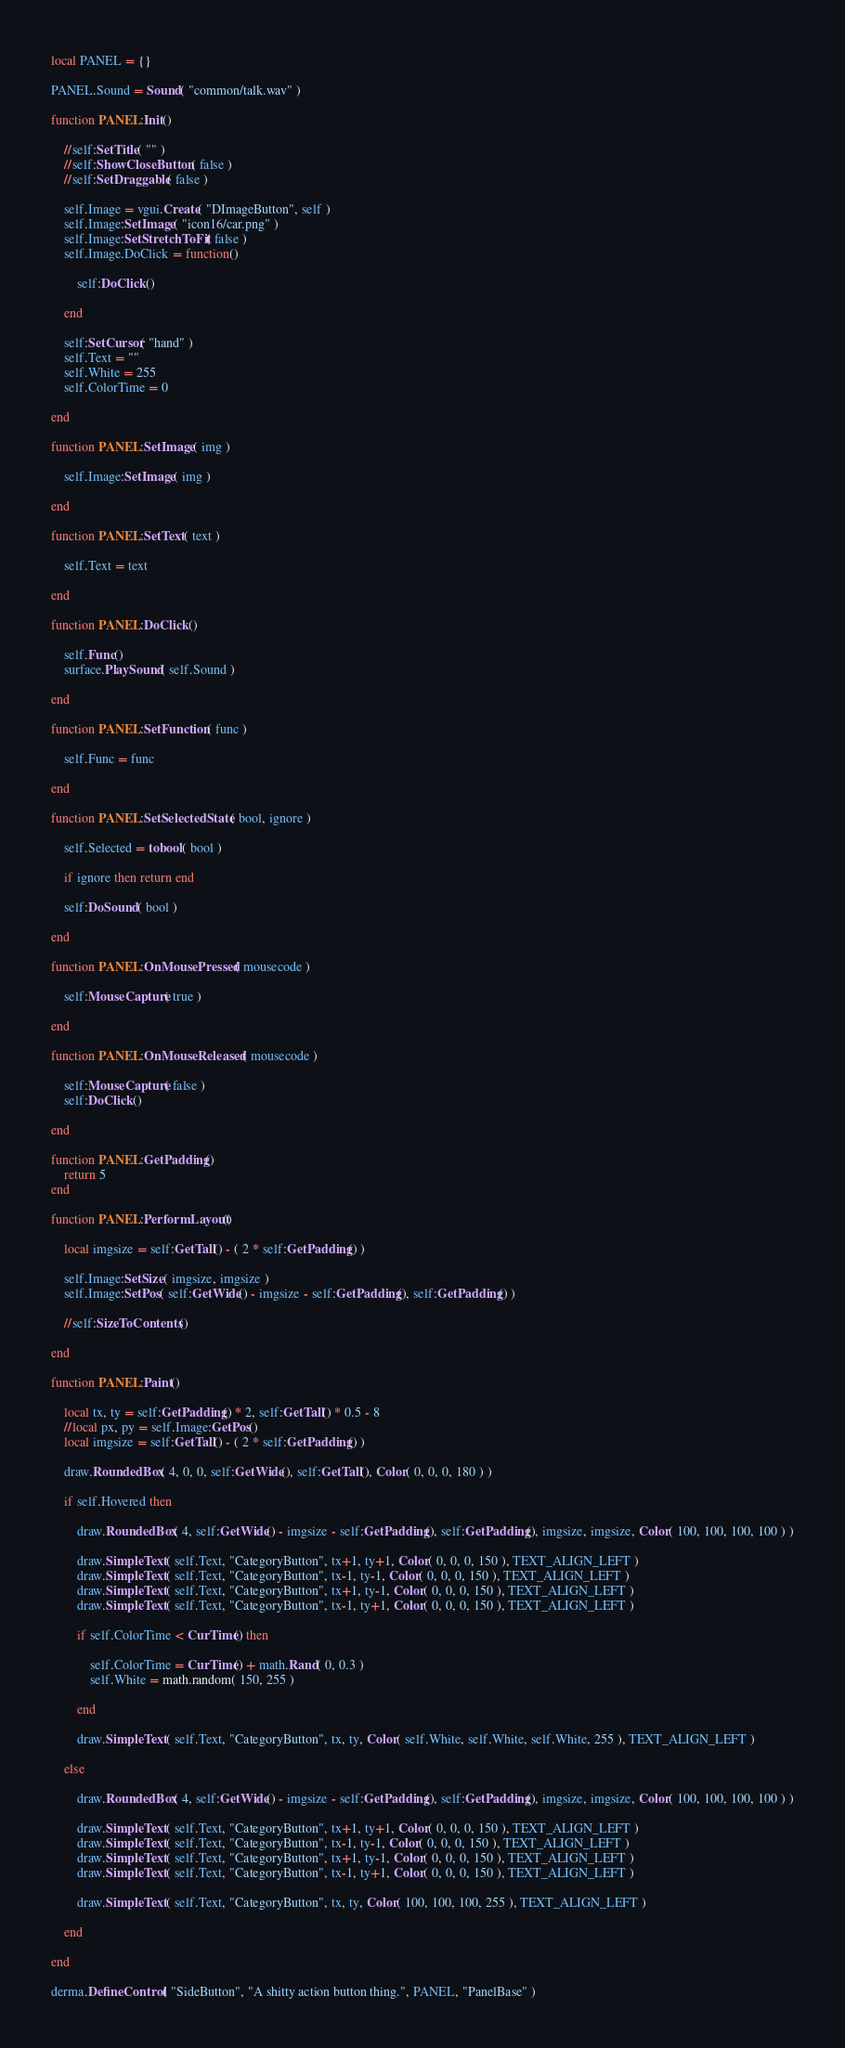Convert code to text. <code><loc_0><loc_0><loc_500><loc_500><_Lua_>local PANEL = {}

PANEL.Sound = Sound( "common/talk.wav" )

function PANEL:Init()

	//self:SetTitle( "" )
	//self:ShowCloseButton( false )
	//self:SetDraggable( false )
	
	self.Image = vgui.Create( "DImageButton", self )
	self.Image:SetImage( "icon16/car.png" )
	self.Image:SetStretchToFit( false )
	self.Image.DoClick = function()
	
		self:DoClick()
	
	end
	
	self:SetCursor( "hand" )
	self.Text = ""
	self.White = 255
	self.ColorTime = 0
	
end

function PANEL:SetImage( img )

	self.Image:SetImage( img )

end

function PANEL:SetText( text )

	self.Text = text

end

function PANEL:DoClick()

	self.Func()
	surface.PlaySound( self.Sound )

end

function PANEL:SetFunction( func ) 

	self.Func = func

end

function PANEL:SetSelectedState( bool, ignore )

	self.Selected = tobool( bool )
	
	if ignore then return end
	
	self:DoSound( bool )

end

function PANEL:OnMousePressed( mousecode )

	self:MouseCapture( true )

end

function PANEL:OnMouseReleased( mousecode )

	self:MouseCapture( false )
	self:DoClick()

end

function PANEL:GetPadding()
	return 5
end

function PANEL:PerformLayout()

	local imgsize = self:GetTall() - ( 2 * self:GetPadding() )

	self.Image:SetSize( imgsize, imgsize )
	self.Image:SetPos( self:GetWide() - imgsize - self:GetPadding(), self:GetPadding() )
	
	//self:SizeToContents()

end

function PANEL:Paint()

	local tx, ty = self:GetPadding() * 2, self:GetTall() * 0.5 - 8
	//local px, py = self.Image:GetPos()
	local imgsize = self:GetTall() - ( 2 * self:GetPadding() )

	draw.RoundedBox( 4, 0, 0, self:GetWide(), self:GetTall(), Color( 0, 0, 0, 180 ) )
	
	if self.Hovered then
	
		draw.RoundedBox( 4, self:GetWide() - imgsize - self:GetPadding(), self:GetPadding(), imgsize, imgsize, Color( 100, 100, 100, 100 ) )
		
		draw.SimpleText( self.Text, "CategoryButton", tx+1, ty+1, Color( 0, 0, 0, 150 ), TEXT_ALIGN_LEFT )
		draw.SimpleText( self.Text, "CategoryButton", tx-1, ty-1, Color( 0, 0, 0, 150 ), TEXT_ALIGN_LEFT )
		draw.SimpleText( self.Text, "CategoryButton", tx+1, ty-1, Color( 0, 0, 0, 150 ), TEXT_ALIGN_LEFT )
		draw.SimpleText( self.Text, "CategoryButton", tx-1, ty+1, Color( 0, 0, 0, 150 ), TEXT_ALIGN_LEFT )
		
		if self.ColorTime < CurTime() then
		
			self.ColorTime = CurTime() + math.Rand( 0, 0.3 )
			self.White = math.random( 150, 255 )
		
		end
		
		draw.SimpleText( self.Text, "CategoryButton", tx, ty, Color( self.White, self.White, self.White, 255 ), TEXT_ALIGN_LEFT )
	
	else

		draw.RoundedBox( 4, self:GetWide() - imgsize - self:GetPadding(), self:GetPadding(), imgsize, imgsize, Color( 100, 100, 100, 100 ) )
		
		draw.SimpleText( self.Text, "CategoryButton", tx+1, ty+1, Color( 0, 0, 0, 150 ), TEXT_ALIGN_LEFT )
		draw.SimpleText( self.Text, "CategoryButton", tx-1, ty-1, Color( 0, 0, 0, 150 ), TEXT_ALIGN_LEFT )
		draw.SimpleText( self.Text, "CategoryButton", tx+1, ty-1, Color( 0, 0, 0, 150 ), TEXT_ALIGN_LEFT )
		draw.SimpleText( self.Text, "CategoryButton", tx-1, ty+1, Color( 0, 0, 0, 150 ), TEXT_ALIGN_LEFT )
		
		draw.SimpleText( self.Text, "CategoryButton", tx, ty, Color( 100, 100, 100, 255 ), TEXT_ALIGN_LEFT )
		
	end

end

derma.DefineControl( "SideButton", "A shitty action button thing.", PANEL, "PanelBase" )
</code> 